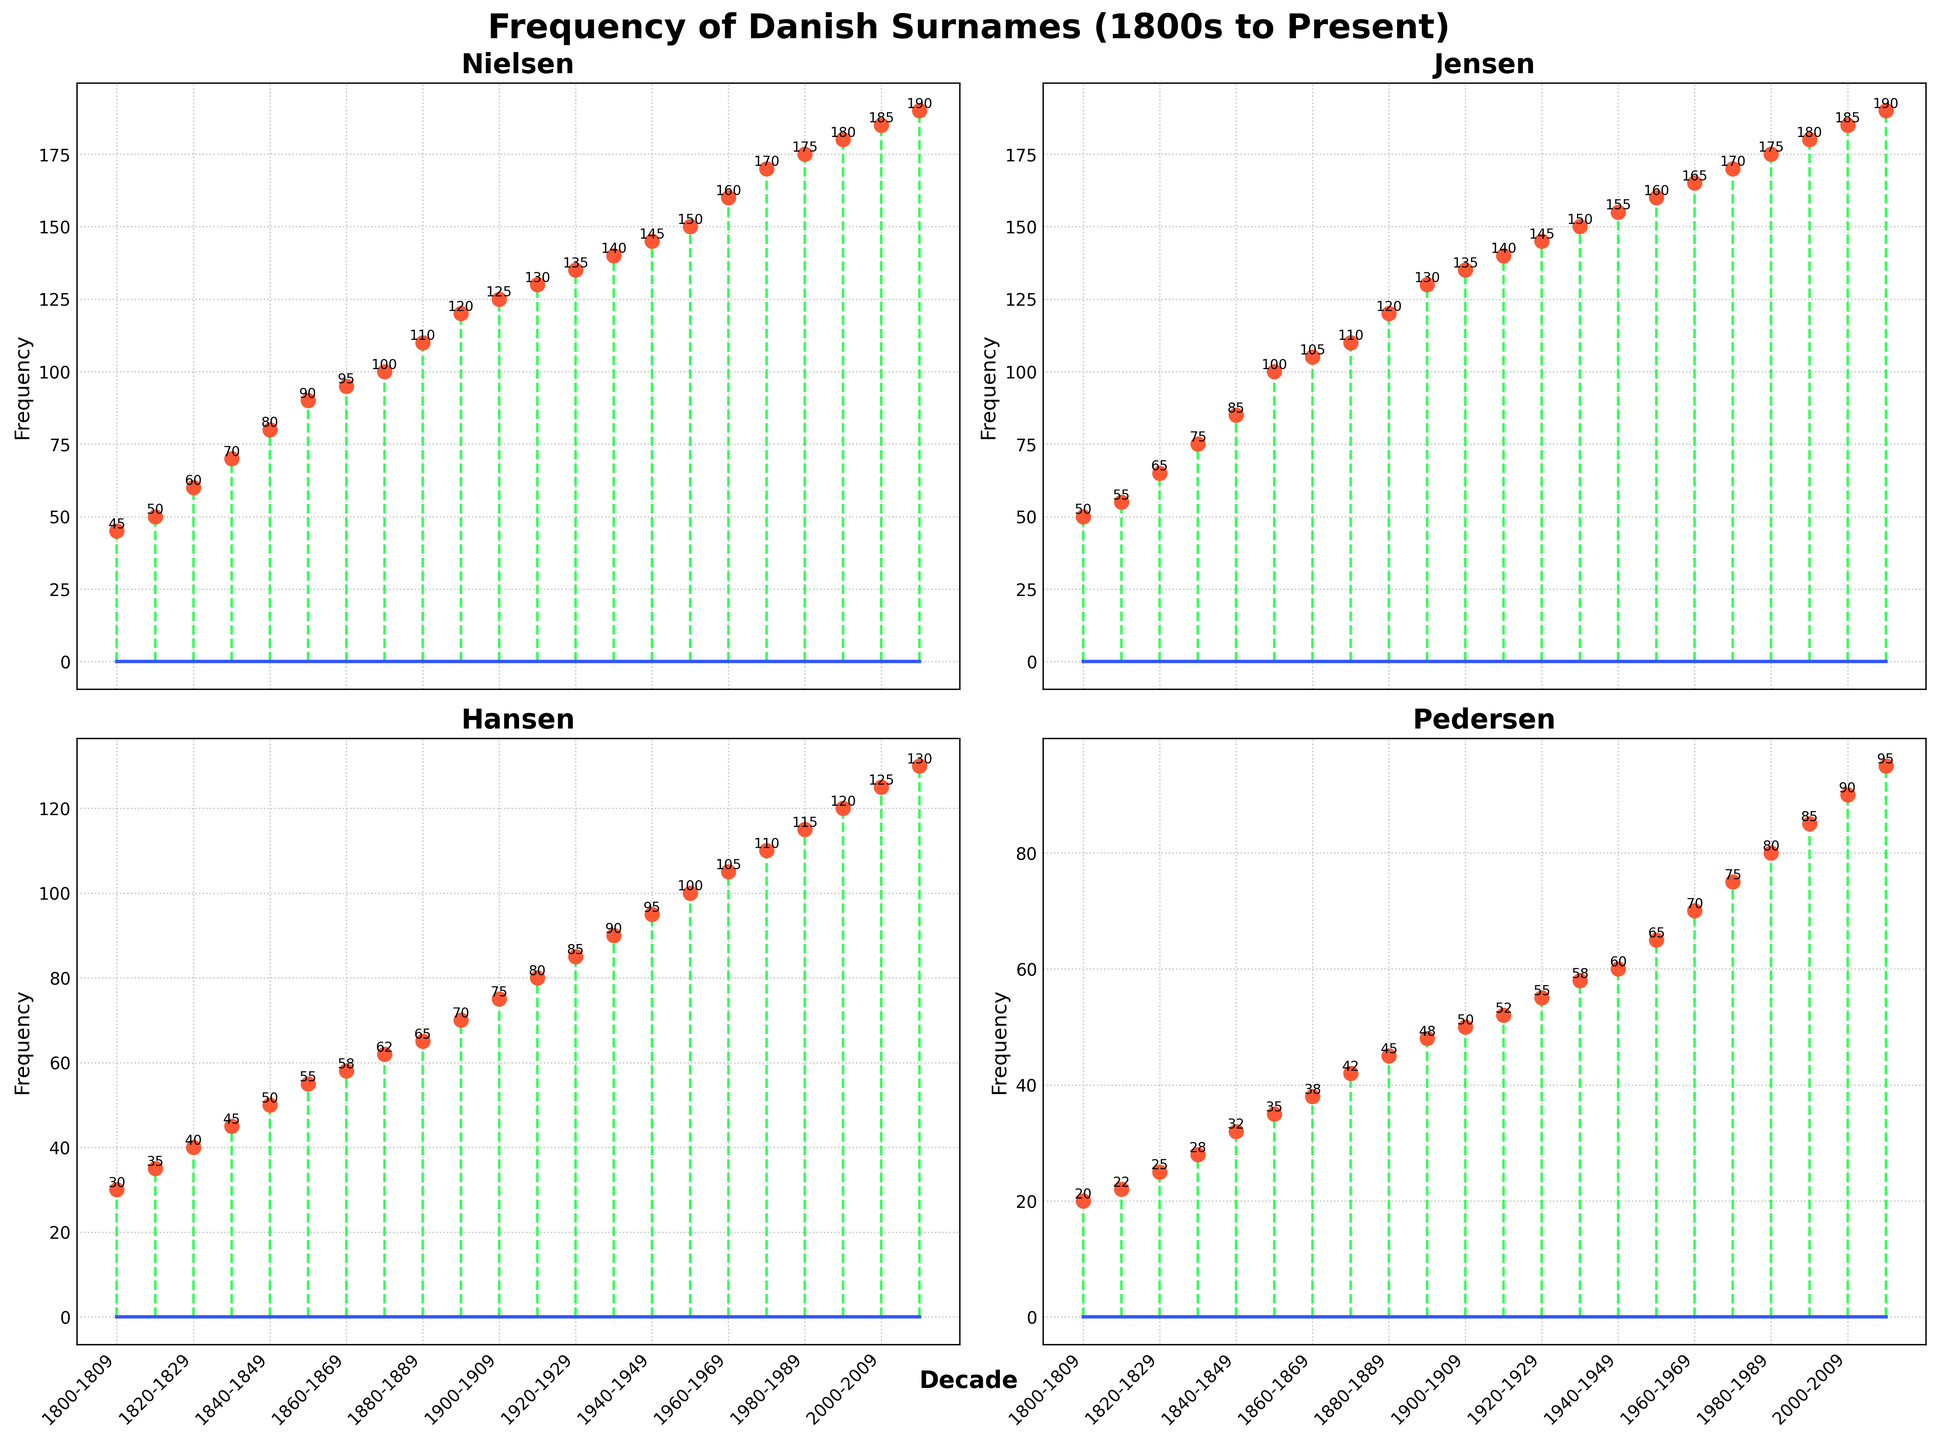What is the title of the figure? The title of the figure is displayed at the top and reads 'Frequency of Danish Surnames (1800s to Present)'.
Answer: Frequency of Danish Surnames (1800s to Present) Which surname shows the highest frequency in the 2010-2019 decade? Look for the data points corresponding to the 2010-2019 decade in each subplot. The highest frequency value among the surnames in that decade is 190, which corresponds to both Nielsen and Jensen.
Answer: Nielsen and Jensen How does the frequency of the surname 'Pedersen' change from the 1800-1809 decade to the 2010-2019 decade? By referring to the Pedersen subplot, note the values for the decades 1800-1809 and 2010-2019. The frequency increases from 20 in 1800-1809 to 95 in 2010-2019.
Answer: It increases from 20 to 95 Which surname has the smallest frequency increment over the entire period from the 1800-1809 decade to the 2010-2019 decade? Calculate the frequency increment for each surname from 1800-1809 to 2010-2019 by subtracting the starting value from the ending value. Compare the results: Nielsen (190 - 45 = 145), Jensen (190 - 50 = 140), Hansen (130 - 30 = 100), Pedersen (95 - 20 = 75). Hence, Pedersen has the smallest increment.
Answer: Pedersen What is the visual difference between the decades' x-ticks on the x-axis for the plot of 'Nielsen' and 'Jensen' compared to the plot of 'Hansen' and 'Pedersen'? The 'Nielsen' and 'Jensen' plots show x-ticks for decades at an interval of every two decades. These x-ticks are also rotated at 45 degrees. This pattern is consistent across all subplots including 'Hansen' and 'Pedersen'.
Answer: All plots have x-ticks for every two decades rotated at 45 degrees In which decade does the surname 'Hansen' reach a frequency of 100 for the first time? Examine the subplot for 'Hansen' and refer to the data points to find when the frequency hits 100. The first decade showing this frequency is 1950-1959.
Answer: 1950-1959 Compare the frequency trends of the surname 'Nielsen' with 'Jensen' over the decades. Which surname shows faster growth? By looking at the overall trends in the subplot, we notice that both surnames start with similar low frequencies and grow over time. Calculating the frequency increase: Nielsen (190 - 45 = 145), Jensen (190 - 50 = 140). The growth rates are very close, but Nielsen has a slightly faster growth.
Answer: Nielsen Which subplot shows the smallest fluctuations in frequency between successive decades? Observe all four subplots for the smallest changes in frequency between decades. 'Pedersen' shows smaller and more gradual changes compared to 'Nielsen', 'Jensen', and 'Hansen'.
Answer: Pedersen How many data points in total are displayed in each subplot? Count the number of data points for any surname subplot since they all share the same structure. Each surname subplot displays frequencies over 22 decades.
Answer: 22 